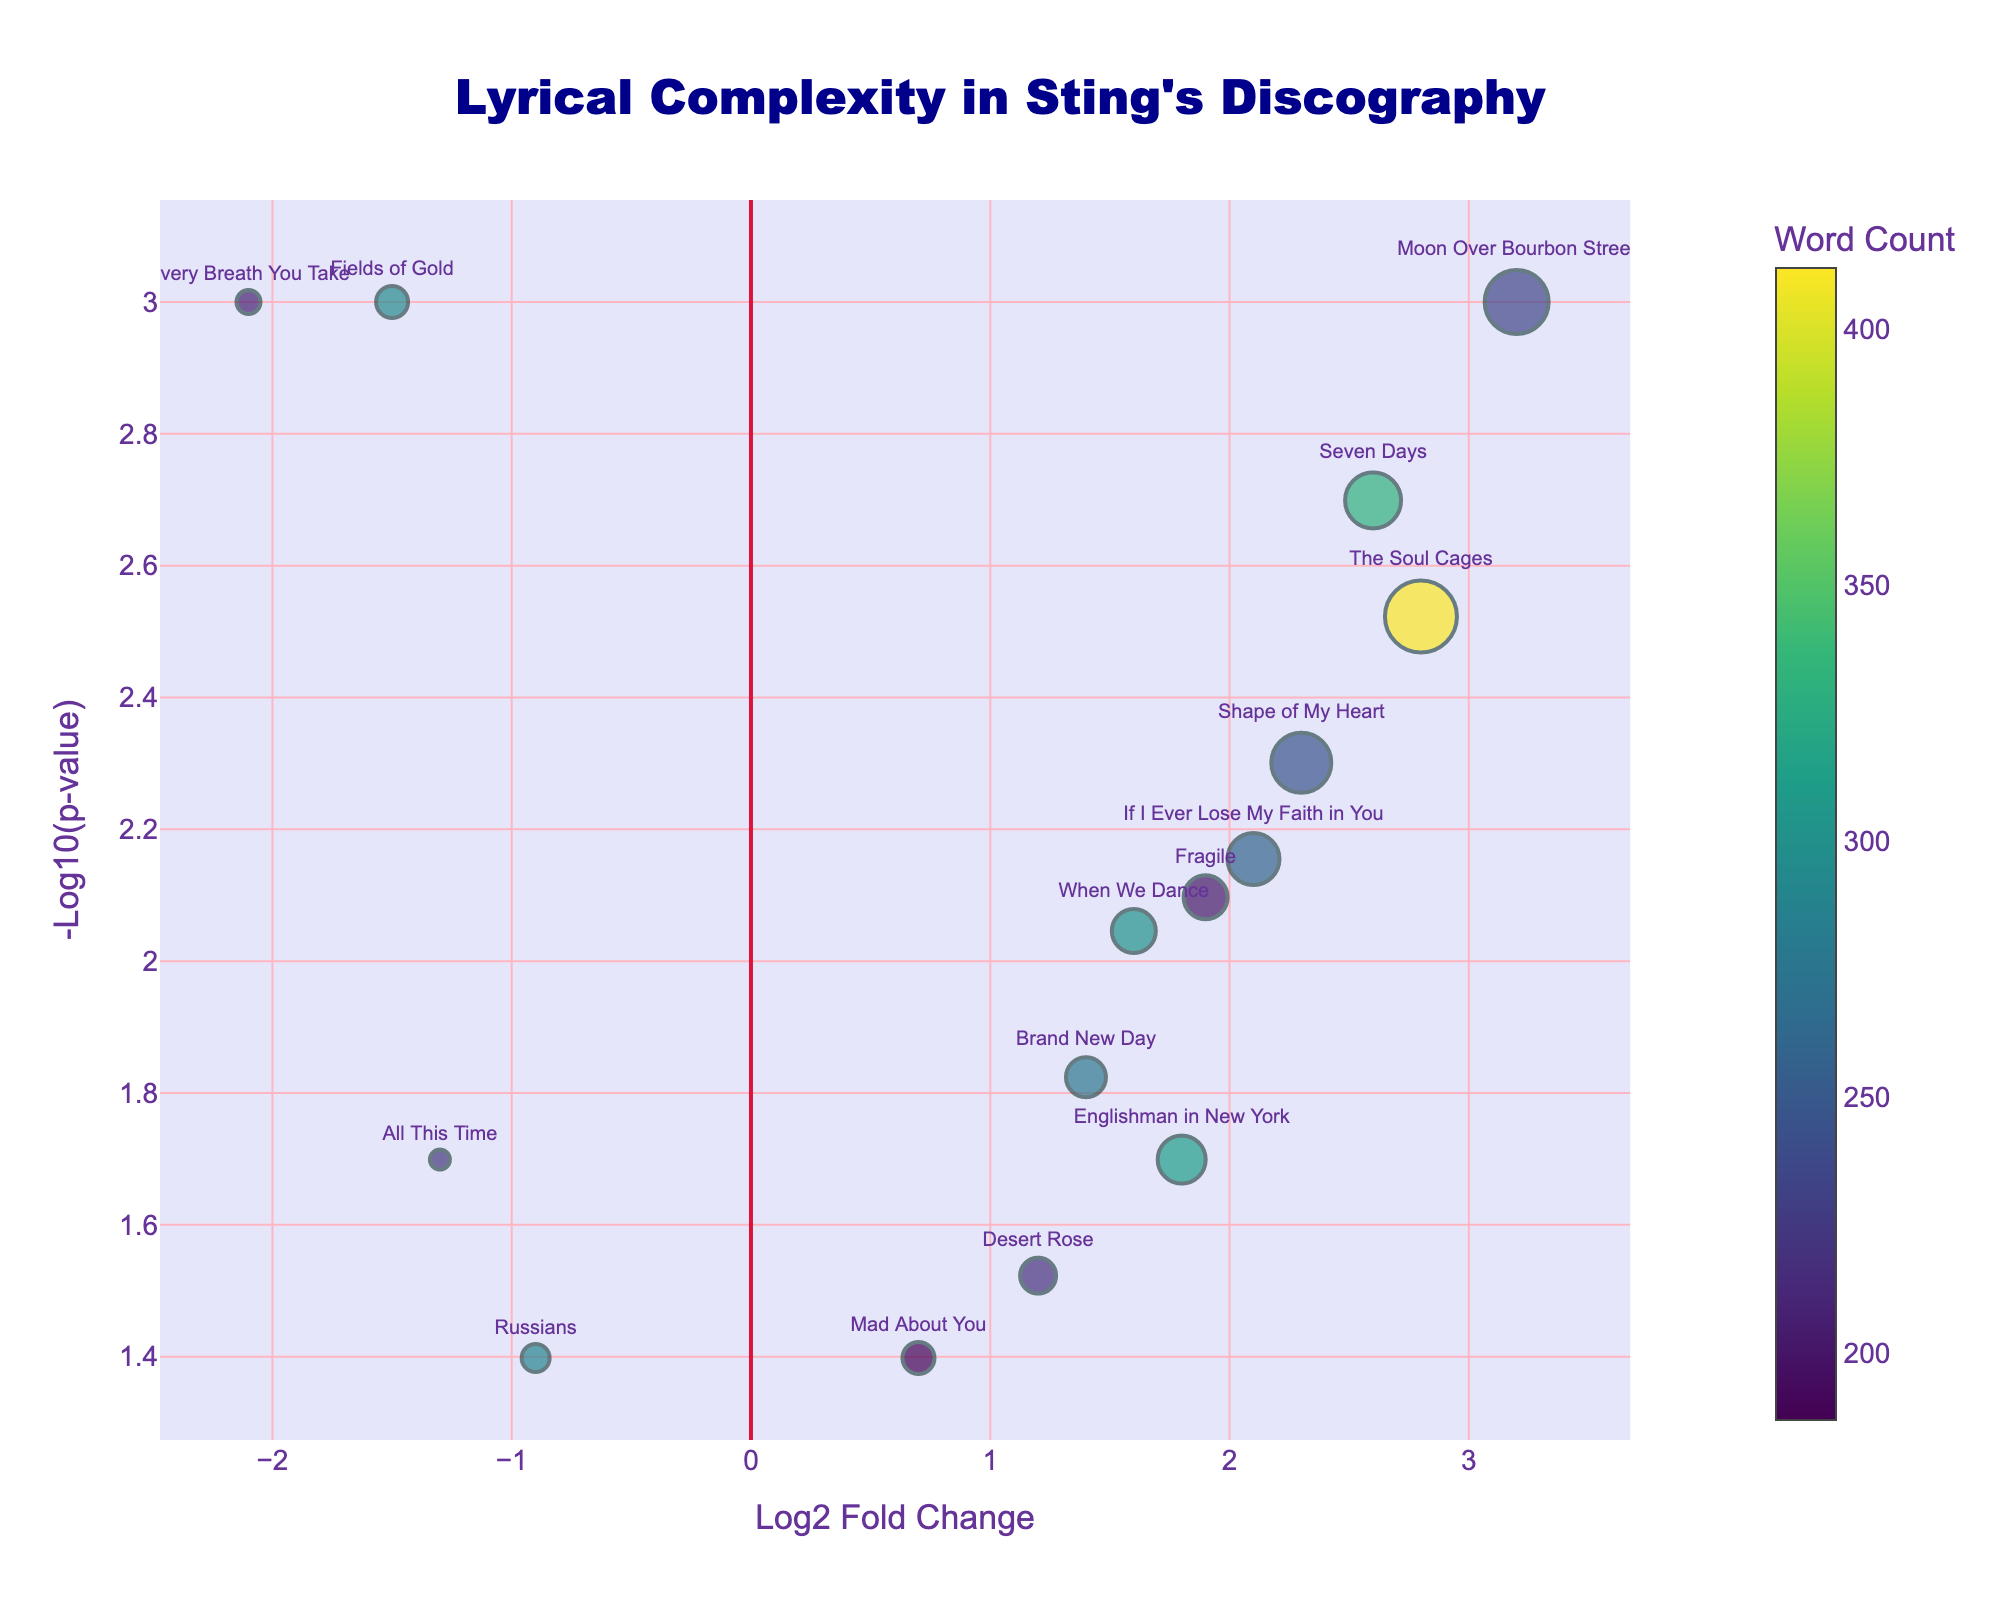What is the title of the figure? The title is usually located at the top of the figure. In this case, it reads "Lyrical Complexity in Sting's Discography".
Answer: "Lyrical Complexity in Sting's Discography" Which song has the highest significance value? The significance value is shown on the y-axis and measures the -log10(p-value). The highest point on the y-axis corresponds to "Moon Over Bourbon Street".
Answer: Moon Over Bourbon Street How many songs have a log2 fold change greater than 2? To find this, count the number of data points with an x-value (log2 fold change) greater than 2. The songs are "Shape of My Heart", "Seven Days", "The Soul Cages", and "Moon Over Bourbon Street".
Answer: 4 Which song has the lowest log2 fold change? The lowest log2 fold change is found on the left side of the x-axis. Here, "Every Breath You Take" has the lowest value.
Answer: Every Breath You Take What is the color used to represent the word count on the color scale? The color scale on the right of the plot indicates that various shades of green through purple (Viridis scale) represent word count.
Answer: Shades of green through purple Which song has the largest marker size and what does the marker size represent? The largest marker size represents the highest metaphor count. "The Soul Cages" and "Moon Over Bourbon Street" both feature the largest marker size with a metaphor count of 18 and 16, respectively.
Answer: The Soul Cages (18) What is the average significance value of songs with negative log2 fold changes? Average significance can be calculated by adding the significance values of songs with negative log2 fold changes and dividing by their count. Songs with negative fold changes: "Fields of Gold", "Every Breath You Take", "Russians", "All This Time". Their significance values are 3, 3, 1.4, and 1.7 respectively. (3 + 3 + 1.4 + 1.7) / 4 = 2.275.
Answer: 2.275 Which song has the highest word count and what is its significance value? The songs' word counts are represented by the color scale. "The Soul Cages" has the highest word count of 412, with a significance value of 2.5.
Answer: The Soul Cages, 2.5 Between “Shape of My Heart” and “Fields of Gold”, which one has more metaphors, and how many more does it have? "Shape of My Heart" has 15 metaphors and "Fields of Gold" has 8 metaphors. 15 - 8 = 7 more metaphors.
Answer: Shape of My Heart, 7 Which songs have significance values above 2 and a positive log2 fold change? Find data points with y-values above 2 and x-values above 0. The songs are "Shape of My Heart", "Seven Days", "The Soul Cages", and "Moon Over Bourbon Street".
Answer: Shape of My Heart, Seven Days, The Soul Cages, Moon Over Bourbon Street 